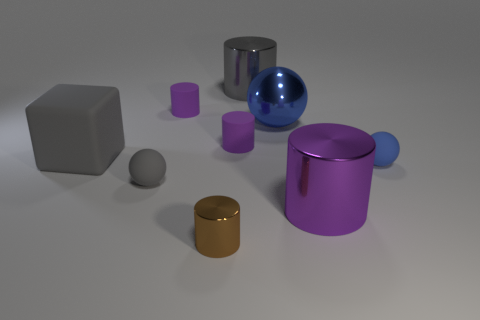Subtract all purple cubes. How many purple cylinders are left? 3 Subtract all green cylinders. Subtract all blue cubes. How many cylinders are left? 5 Add 1 big gray shiny things. How many objects exist? 10 Subtract all cylinders. How many objects are left? 4 Add 6 gray spheres. How many gray spheres exist? 7 Subtract 0 yellow cubes. How many objects are left? 9 Subtract all large yellow shiny cylinders. Subtract all purple metallic objects. How many objects are left? 8 Add 7 blue spheres. How many blue spheres are left? 9 